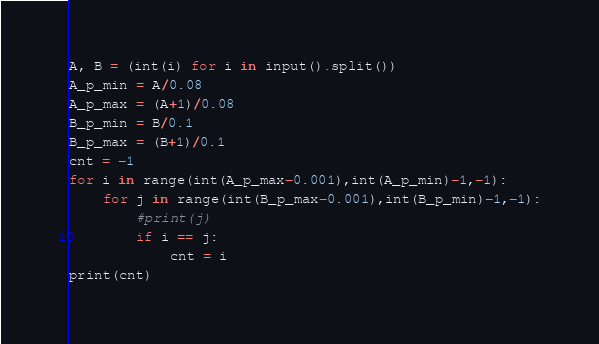<code> <loc_0><loc_0><loc_500><loc_500><_Python_>A, B = (int(i) for i in input().split())  
A_p_min = A/0.08
A_p_max = (A+1)/0.08
B_p_min = B/0.1
B_p_max = (B+1)/0.1
cnt = -1
for i in range(int(A_p_max-0.001),int(A_p_min)-1,-1):
    for j in range(int(B_p_max-0.001),int(B_p_min)-1,-1):
        #print(j)
        if i == j:
            cnt = i
print(cnt)</code> 